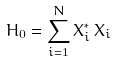<formula> <loc_0><loc_0><loc_500><loc_500>H _ { 0 } = \sum ^ { N } _ { i = 1 } X _ { i } ^ { * } \, X _ { i }</formula> 